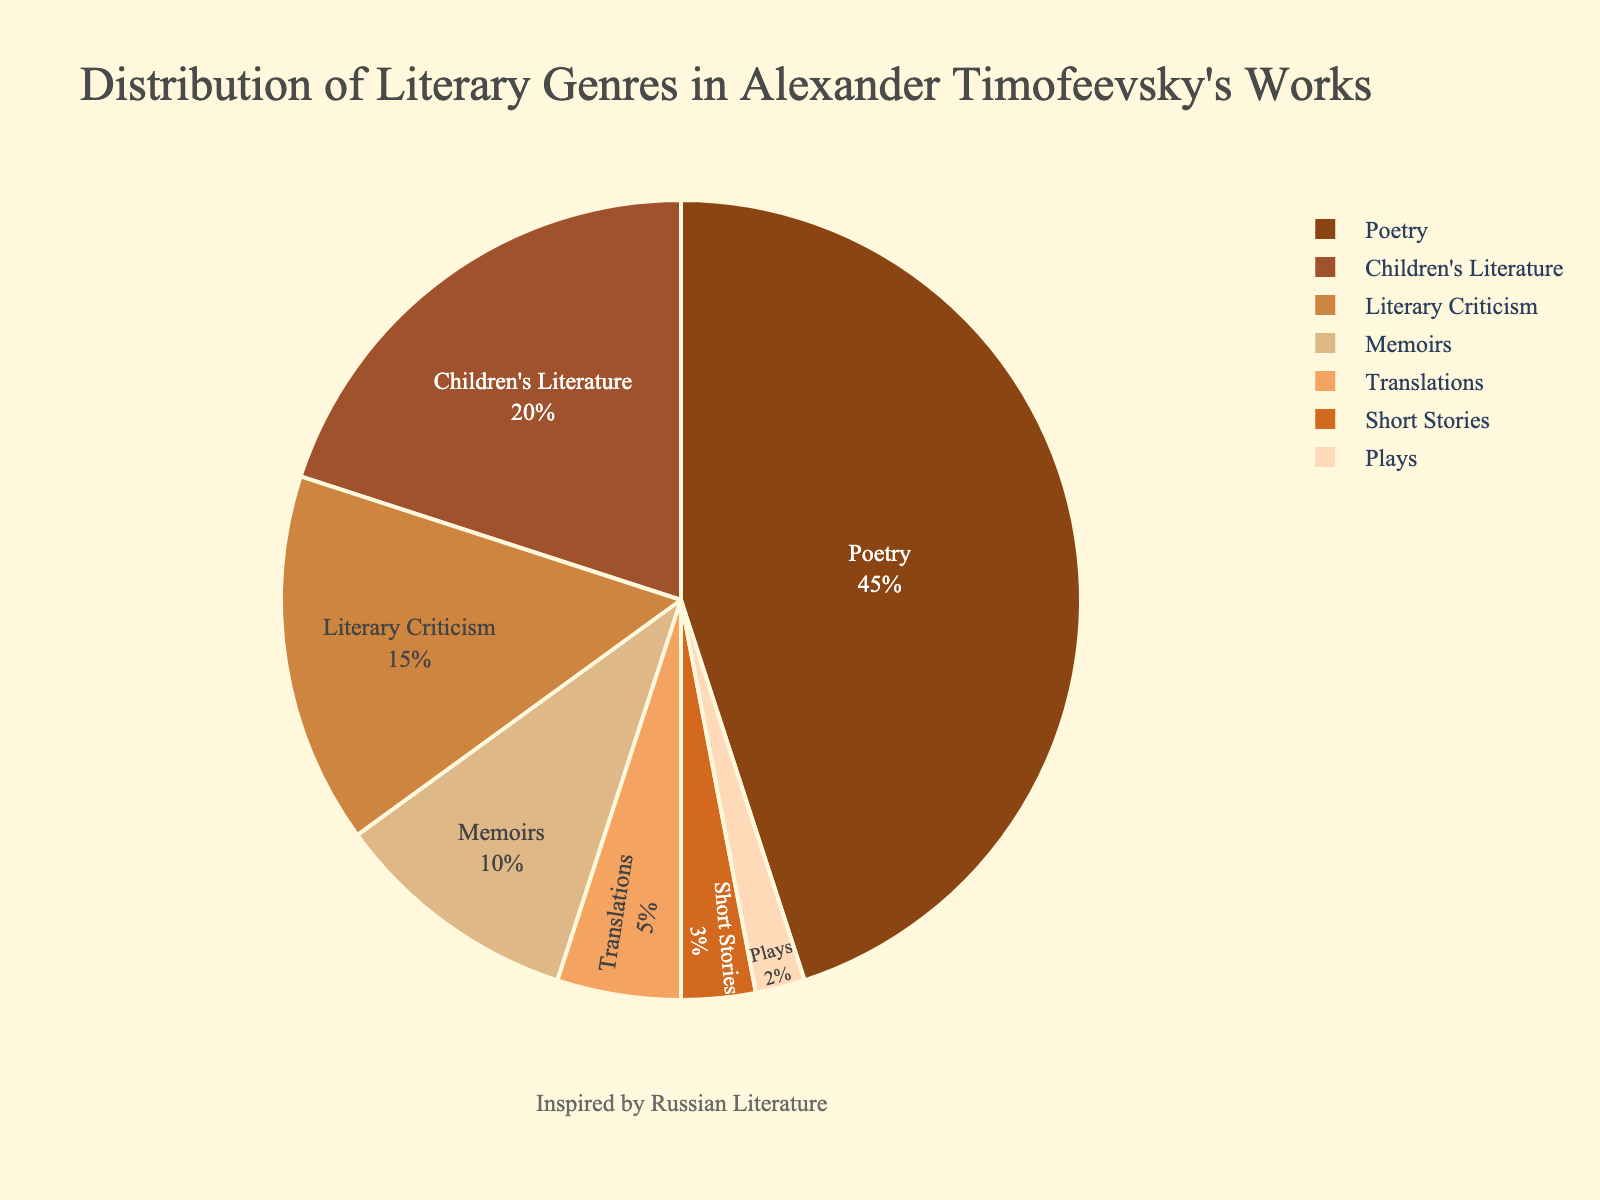What genre constitutes the largest portion of Alexander Timofeevsky's works according to the pie chart? The largest portion of the pie chart is occupied by the genre "Poetry". Its segment is visibly larger than the others.
Answer: Poetry Which two genres combined make up exactly half of Timofeevsky's works? The "Poetry" segment comprises 45% and the "Children's Literature" segment comprises 20%. Combined, they total 45% + 20% = 65%. No two genres in the chart sum up to exactly 50%, but considering percentages exactly would show it’s not possible.
Answer: None How much larger is the "Poetry" segment compared to the "Translations" segment? "Poetry" is 45% and "Translations" is 5%. Subtracting these values gives 45% - 5% = 40%.
Answer: 40% Are there any genres that collectively make up less than 10% of the total? The segments for "Short Stories" (3%) and "Plays" (2%) collectively total 3% + 2% = 5%, which is less than 10%.
Answer: Yes What is the visual color associated with the genre "Memoirs" in the pie chart? The pie chart uses a color palette. The segment representing "Memoirs" is depicted using a beige-like color which is distinguishable from others.
Answer: Beige-like If you total the percentages of "Literary Criticism" and "Children's Literature", how much of the total does this account for? "Literary Criticism" accounts for 15% and "Children's Literature" accounts for 20%. Adding these gives 15% + 20% = 35%.
Answer: 35% Which genre holds a smaller percentage compared to "Memoirs"? "Memoirs" hold 10% of the works. The genres with smaller percentages are "Translations" (5%), "Short Stories" (3%), and "Plays" (2%).
Answer: Translations, Short Stories, Plays What is the total percentage of all genres that are not "Poetry"? Exclude the percentage for "Poetry" and add the rest: 20% + 15% + 10% + 5% + 3% + 2% = 55%.
Answer: 55% 